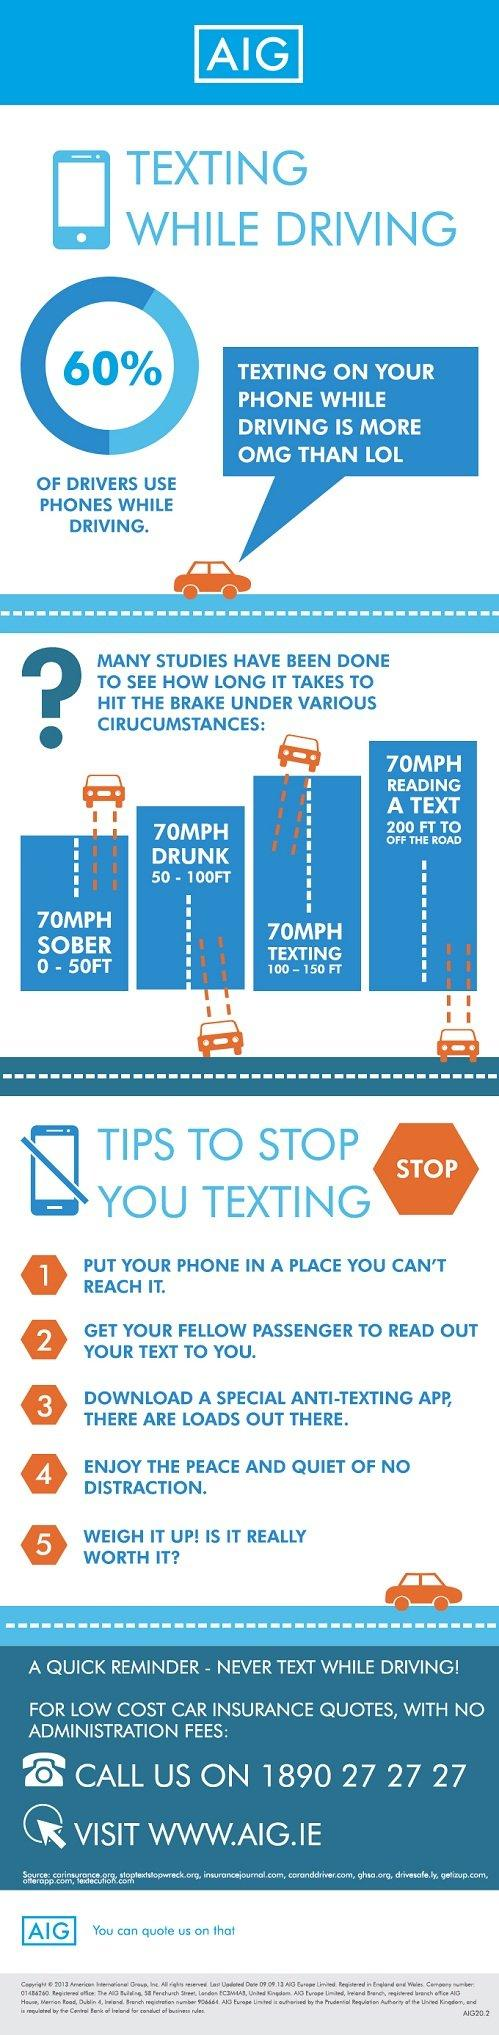Identify some key points in this picture. Approximately 40% of individuals who use their phone while driving. The driver may take a significant amount of time to apply the brakes when texting, up to 100-150 feet. 